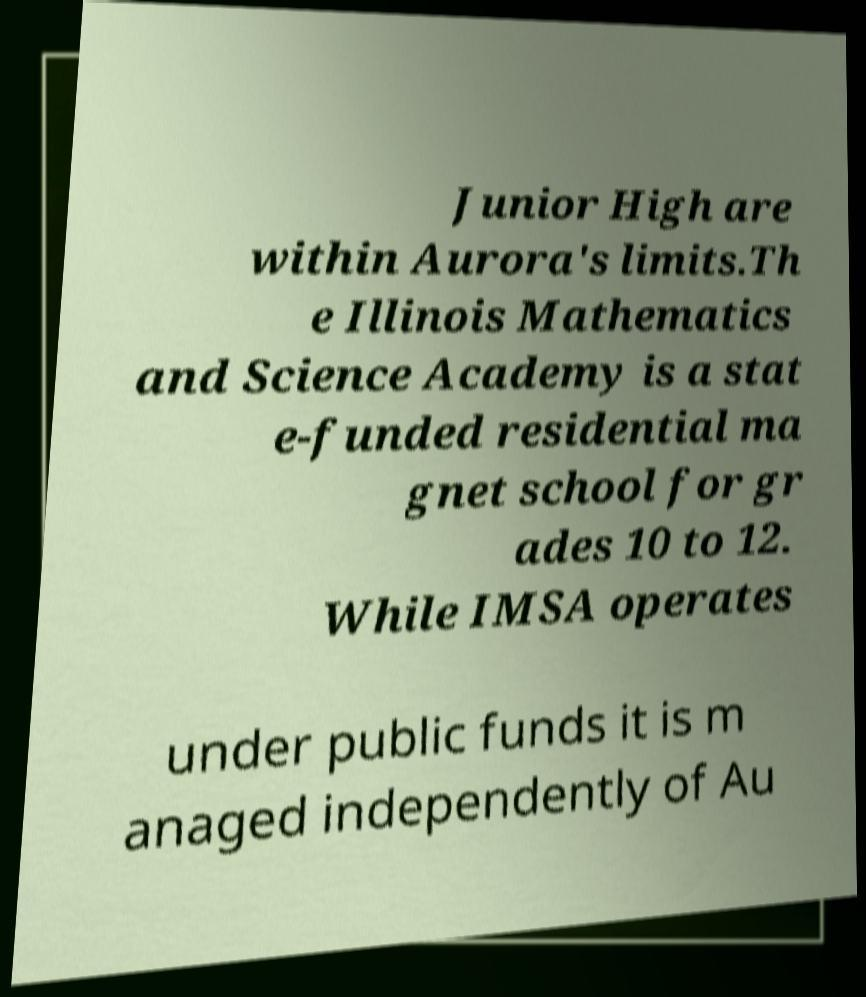Please identify and transcribe the text found in this image. Junior High are within Aurora's limits.Th e Illinois Mathematics and Science Academy is a stat e-funded residential ma gnet school for gr ades 10 to 12. While IMSA operates under public funds it is m anaged independently of Au 